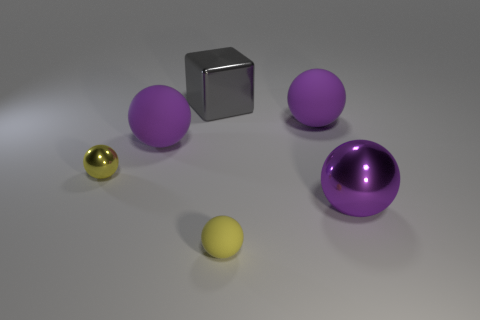Is there any pattern or alignment to the arrangement of these items? The arrangement of the items does not follow an easily discernable pattern or alignment. The objects are placed at varying distances from each other, with no obvious formation. The mix of materials and colors creates an aesthetically pleasing, yet random, assortment. 